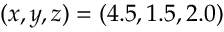<formula> <loc_0><loc_0><loc_500><loc_500>( x , y , z ) = ( 4 . 5 , 1 . 5 , 2 . 0 )</formula> 